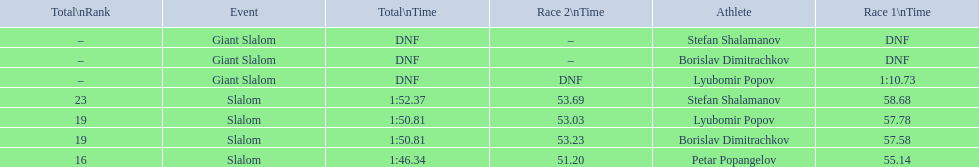How many athletes finished the first race in the giant slalom? 1. 